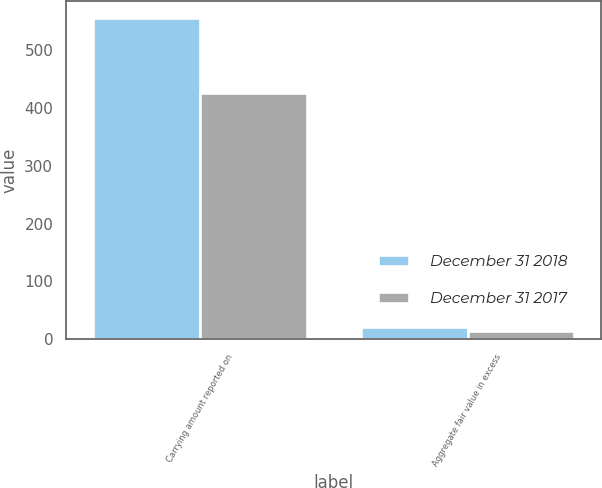<chart> <loc_0><loc_0><loc_500><loc_500><stacked_bar_chart><ecel><fcel>Carrying amount reported on<fcel>Aggregate fair value in excess<nl><fcel>December 31 2018<fcel>556<fcel>21<nl><fcel>December 31 2017<fcel>426<fcel>14<nl></chart> 